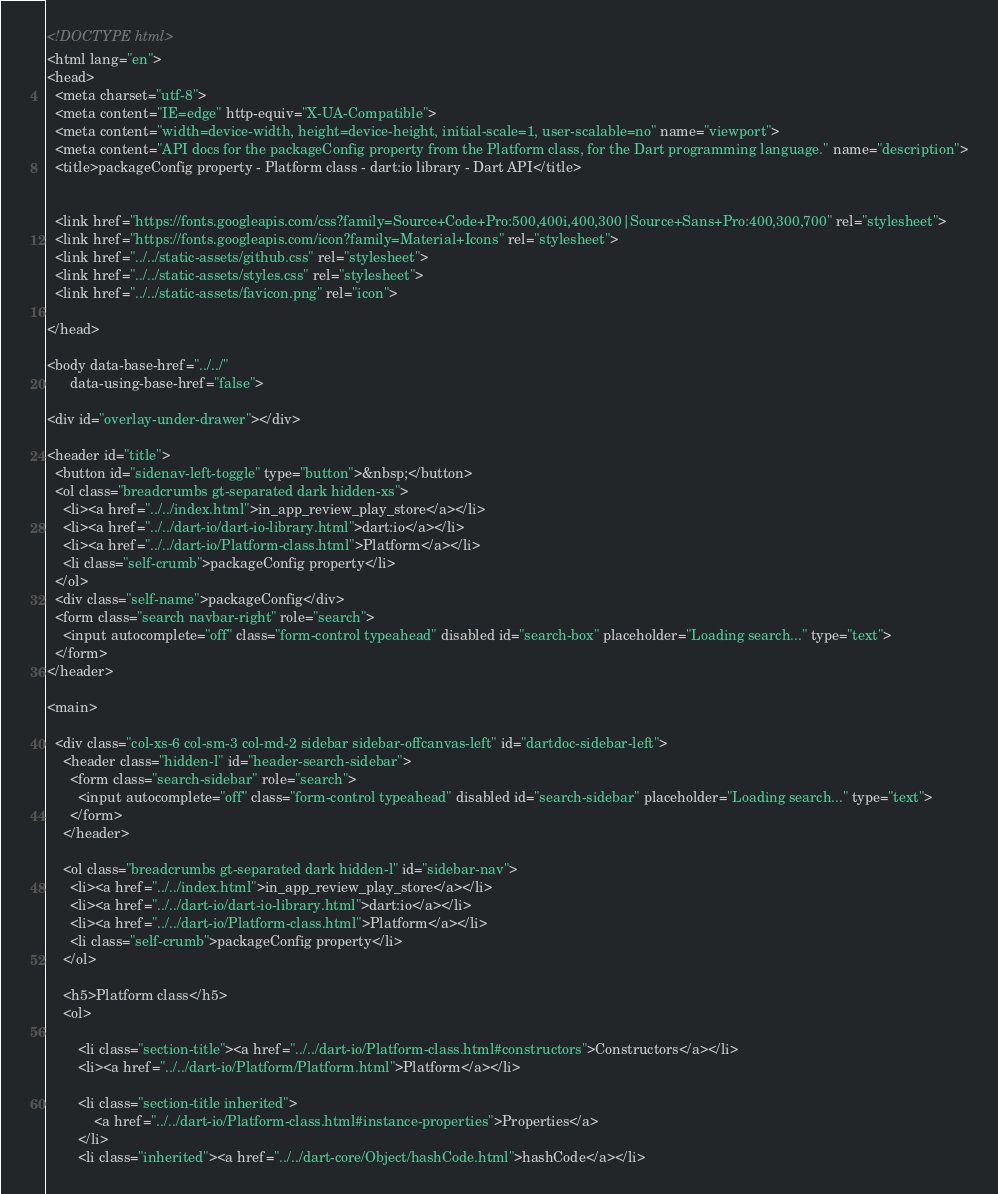Convert code to text. <code><loc_0><loc_0><loc_500><loc_500><_HTML_><!DOCTYPE html>
<html lang="en">
<head>
  <meta charset="utf-8">
  <meta content="IE=edge" http-equiv="X-UA-Compatible">
  <meta content="width=device-width, height=device-height, initial-scale=1, user-scalable=no" name="viewport">
  <meta content="API docs for the packageConfig property from the Platform class, for the Dart programming language." name="description">
  <title>packageConfig property - Platform class - dart:io library - Dart API</title>

  
  <link href="https://fonts.googleapis.com/css?family=Source+Code+Pro:500,400i,400,300|Source+Sans+Pro:400,300,700" rel="stylesheet">
  <link href="https://fonts.googleapis.com/icon?family=Material+Icons" rel="stylesheet">
  <link href="../../static-assets/github.css" rel="stylesheet">
  <link href="../../static-assets/styles.css" rel="stylesheet">
  <link href="../../static-assets/favicon.png" rel="icon">

</head>

<body data-base-href="../../"
      data-using-base-href="false">

<div id="overlay-under-drawer"></div>

<header id="title">
  <button id="sidenav-left-toggle" type="button">&nbsp;</button>
  <ol class="breadcrumbs gt-separated dark hidden-xs">
    <li><a href="../../index.html">in_app_review_play_store</a></li>
    <li><a href="../../dart-io/dart-io-library.html">dart:io</a></li>
    <li><a href="../../dart-io/Platform-class.html">Platform</a></li>
    <li class="self-crumb">packageConfig property</li>
  </ol>
  <div class="self-name">packageConfig</div>
  <form class="search navbar-right" role="search">
    <input autocomplete="off" class="form-control typeahead" disabled id="search-box" placeholder="Loading search..." type="text">
  </form>
</header>

<main>

  <div class="col-xs-6 col-sm-3 col-md-2 sidebar sidebar-offcanvas-left" id="dartdoc-sidebar-left">
    <header class="hidden-l" id="header-search-sidebar">
      <form class="search-sidebar" role="search">
        <input autocomplete="off" class="form-control typeahead" disabled id="search-sidebar" placeholder="Loading search..." type="text">
      </form>
    </header>
    
    <ol class="breadcrumbs gt-separated dark hidden-l" id="sidebar-nav">
      <li><a href="../../index.html">in_app_review_play_store</a></li>
      <li><a href="../../dart-io/dart-io-library.html">dart:io</a></li>
      <li><a href="../../dart-io/Platform-class.html">Platform</a></li>
      <li class="self-crumb">packageConfig property</li>
    </ol>
    
    <h5>Platform class</h5>
    <ol>
    
        <li class="section-title"><a href="../../dart-io/Platform-class.html#constructors">Constructors</a></li>
        <li><a href="../../dart-io/Platform/Platform.html">Platform</a></li>
    
        <li class="section-title inherited">
            <a href="../../dart-io/Platform-class.html#instance-properties">Properties</a>
        </li>
        <li class="inherited"><a href="../../dart-core/Object/hashCode.html">hashCode</a></li></code> 